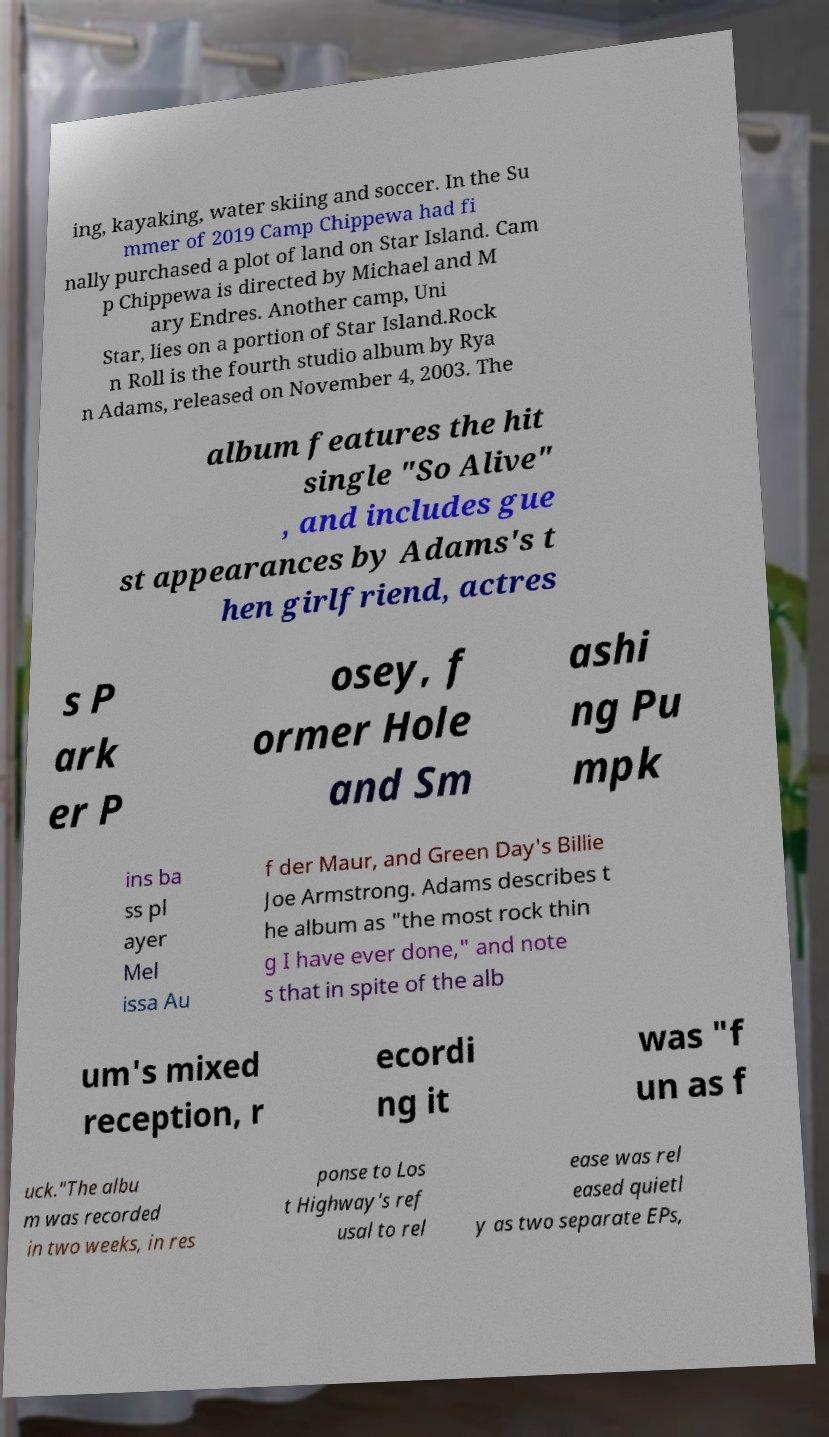For documentation purposes, I need the text within this image transcribed. Could you provide that? ing, kayaking, water skiing and soccer. In the Su mmer of 2019 Camp Chippewa had fi nally purchased a plot of land on Star Island. Cam p Chippewa is directed by Michael and M ary Endres. Another camp, Uni Star, lies on a portion of Star Island.Rock n Roll is the fourth studio album by Rya n Adams, released on November 4, 2003. The album features the hit single "So Alive" , and includes gue st appearances by Adams's t hen girlfriend, actres s P ark er P osey, f ormer Hole and Sm ashi ng Pu mpk ins ba ss pl ayer Mel issa Au f der Maur, and Green Day's Billie Joe Armstrong. Adams describes t he album as "the most rock thin g I have ever done," and note s that in spite of the alb um's mixed reception, r ecordi ng it was "f un as f uck."The albu m was recorded in two weeks, in res ponse to Los t Highway's ref usal to rel ease was rel eased quietl y as two separate EPs, 